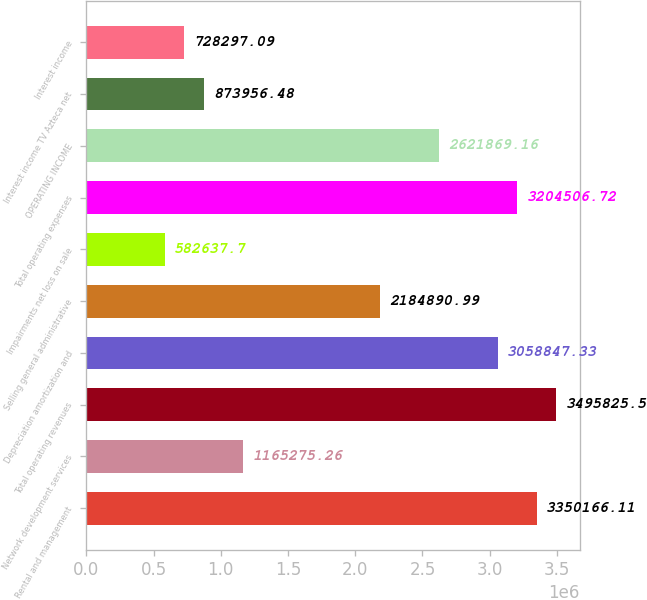Convert chart to OTSL. <chart><loc_0><loc_0><loc_500><loc_500><bar_chart><fcel>Rental and management<fcel>Network development services<fcel>Total operating revenues<fcel>Depreciation amortization and<fcel>Selling general administrative<fcel>Impairments net loss on sale<fcel>Total operating expenses<fcel>OPERATING INCOME<fcel>Interest income TV Azteca net<fcel>Interest income<nl><fcel>3.35017e+06<fcel>1.16528e+06<fcel>3.49583e+06<fcel>3.05885e+06<fcel>2.18489e+06<fcel>582638<fcel>3.20451e+06<fcel>2.62187e+06<fcel>873956<fcel>728297<nl></chart> 